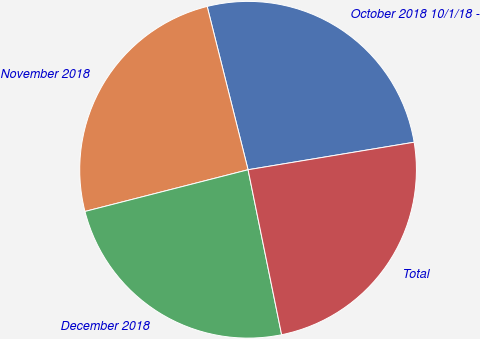Convert chart to OTSL. <chart><loc_0><loc_0><loc_500><loc_500><pie_chart><fcel>October 2018 10/1/18 -<fcel>November 2018<fcel>December 2018<fcel>Total<nl><fcel>26.29%<fcel>25.08%<fcel>24.21%<fcel>24.42%<nl></chart> 